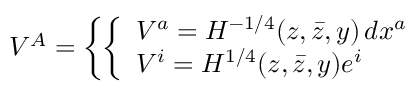<formula> <loc_0><loc_0><loc_500><loc_500>V ^ { A } = \left \{ \left \{ \begin{array} { l l } { { V ^ { a } = H ^ { - 1 / 4 } ( z , \bar { z } , y ) \, d x ^ { a } } } \\ { { V ^ { i } = H ^ { 1 / 4 } ( z , \bar { z } , y ) e ^ { i } } } \end{array}</formula> 